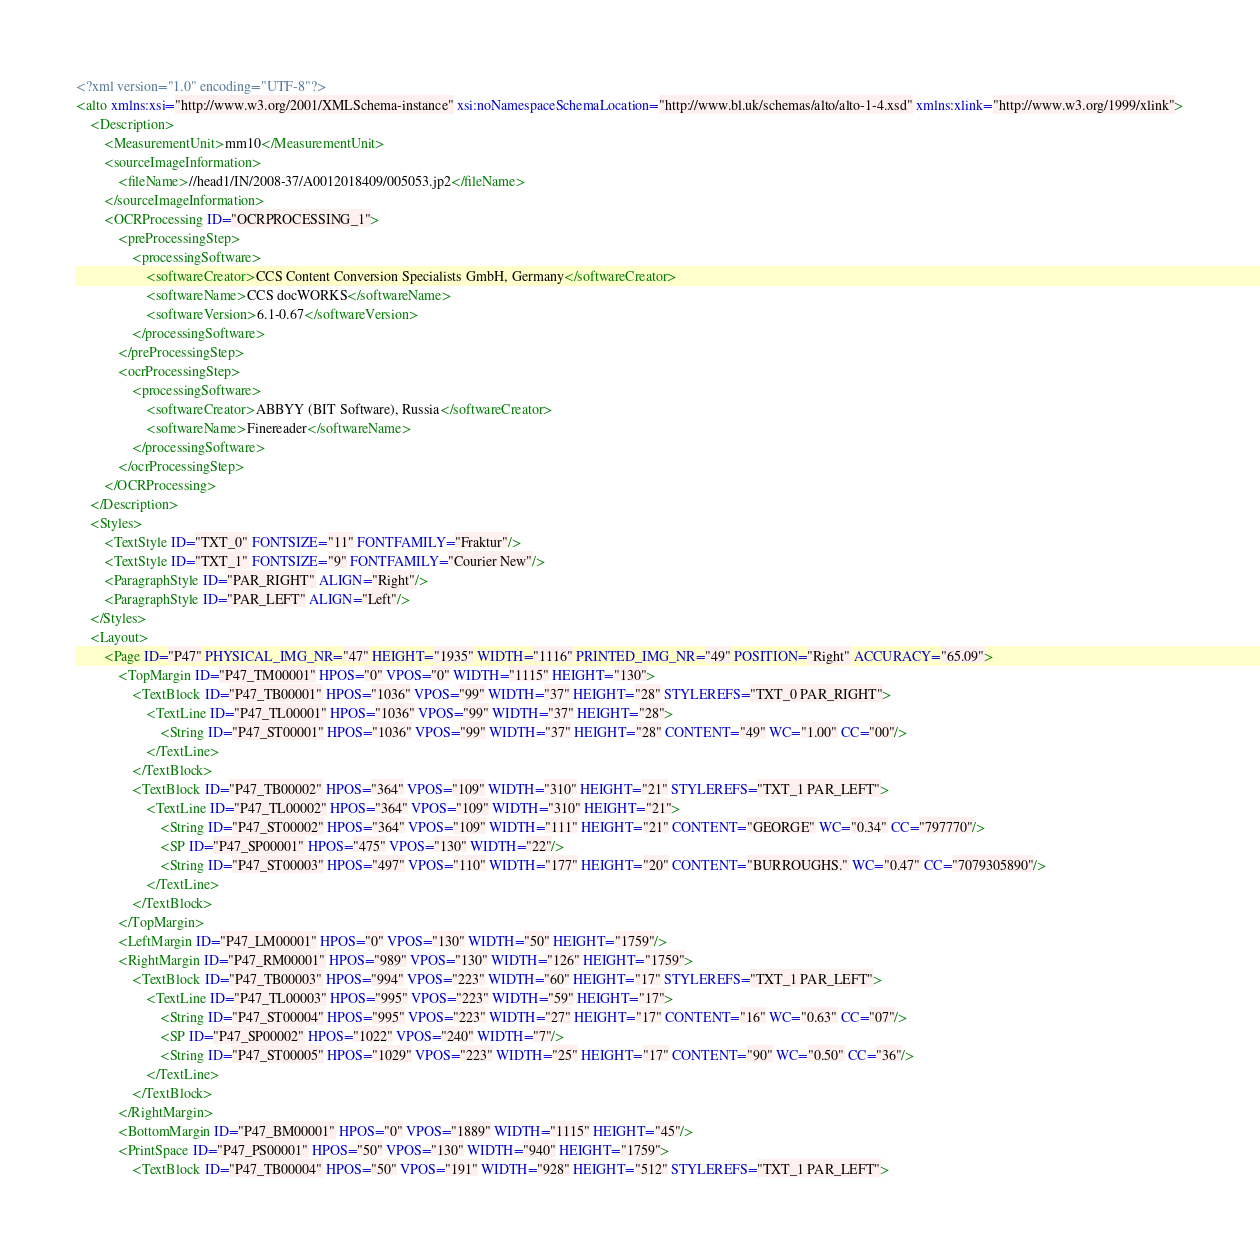<code> <loc_0><loc_0><loc_500><loc_500><_XML_><?xml version="1.0" encoding="UTF-8"?>
<alto xmlns:xsi="http://www.w3.org/2001/XMLSchema-instance" xsi:noNamespaceSchemaLocation="http://www.bl.uk/schemas/alto/alto-1-4.xsd" xmlns:xlink="http://www.w3.org/1999/xlink">
	<Description>
		<MeasurementUnit>mm10</MeasurementUnit>
		<sourceImageInformation>
			<fileName>//head1/IN/2008-37/A0012018409/005053.jp2</fileName>
		</sourceImageInformation>
		<OCRProcessing ID="OCRPROCESSING_1">
			<preProcessingStep>
				<processingSoftware>
					<softwareCreator>CCS Content Conversion Specialists GmbH, Germany</softwareCreator>
					<softwareName>CCS docWORKS</softwareName>
					<softwareVersion>6.1-0.67</softwareVersion>
				</processingSoftware>
			</preProcessingStep>
			<ocrProcessingStep>
				<processingSoftware>
					<softwareCreator>ABBYY (BIT Software), Russia</softwareCreator>
					<softwareName>Finereader</softwareName>
				</processingSoftware>
			</ocrProcessingStep>
		</OCRProcessing>
	</Description>
	<Styles>
		<TextStyle ID="TXT_0" FONTSIZE="11" FONTFAMILY="Fraktur"/>
		<TextStyle ID="TXT_1" FONTSIZE="9" FONTFAMILY="Courier New"/>
		<ParagraphStyle ID="PAR_RIGHT" ALIGN="Right"/>
		<ParagraphStyle ID="PAR_LEFT" ALIGN="Left"/>
	</Styles>
	<Layout>
		<Page ID="P47" PHYSICAL_IMG_NR="47" HEIGHT="1935" WIDTH="1116" PRINTED_IMG_NR="49" POSITION="Right" ACCURACY="65.09">
			<TopMargin ID="P47_TM00001" HPOS="0" VPOS="0" WIDTH="1115" HEIGHT="130">
				<TextBlock ID="P47_TB00001" HPOS="1036" VPOS="99" WIDTH="37" HEIGHT="28" STYLEREFS="TXT_0 PAR_RIGHT">
					<TextLine ID="P47_TL00001" HPOS="1036" VPOS="99" WIDTH="37" HEIGHT="28">
						<String ID="P47_ST00001" HPOS="1036" VPOS="99" WIDTH="37" HEIGHT="28" CONTENT="49" WC="1.00" CC="00"/>
					</TextLine>
				</TextBlock>
				<TextBlock ID="P47_TB00002" HPOS="364" VPOS="109" WIDTH="310" HEIGHT="21" STYLEREFS="TXT_1 PAR_LEFT">
					<TextLine ID="P47_TL00002" HPOS="364" VPOS="109" WIDTH="310" HEIGHT="21">
						<String ID="P47_ST00002" HPOS="364" VPOS="109" WIDTH="111" HEIGHT="21" CONTENT="GEORGE" WC="0.34" CC="797770"/>
						<SP ID="P47_SP00001" HPOS="475" VPOS="130" WIDTH="22"/>
						<String ID="P47_ST00003" HPOS="497" VPOS="110" WIDTH="177" HEIGHT="20" CONTENT="BURROUGHS." WC="0.47" CC="7079305890"/>
					</TextLine>
				</TextBlock>
			</TopMargin>
			<LeftMargin ID="P47_LM00001" HPOS="0" VPOS="130" WIDTH="50" HEIGHT="1759"/>
			<RightMargin ID="P47_RM00001" HPOS="989" VPOS="130" WIDTH="126" HEIGHT="1759">
				<TextBlock ID="P47_TB00003" HPOS="994" VPOS="223" WIDTH="60" HEIGHT="17" STYLEREFS="TXT_1 PAR_LEFT">
					<TextLine ID="P47_TL00003" HPOS="995" VPOS="223" WIDTH="59" HEIGHT="17">
						<String ID="P47_ST00004" HPOS="995" VPOS="223" WIDTH="27" HEIGHT="17" CONTENT="16" WC="0.63" CC="07"/>
						<SP ID="P47_SP00002" HPOS="1022" VPOS="240" WIDTH="7"/>
						<String ID="P47_ST00005" HPOS="1029" VPOS="223" WIDTH="25" HEIGHT="17" CONTENT="90" WC="0.50" CC="36"/>
					</TextLine>
				</TextBlock>
			</RightMargin>
			<BottomMargin ID="P47_BM00001" HPOS="0" VPOS="1889" WIDTH="1115" HEIGHT="45"/>
			<PrintSpace ID="P47_PS00001" HPOS="50" VPOS="130" WIDTH="940" HEIGHT="1759">
				<TextBlock ID="P47_TB00004" HPOS="50" VPOS="191" WIDTH="928" HEIGHT="512" STYLEREFS="TXT_1 PAR_LEFT"></code> 